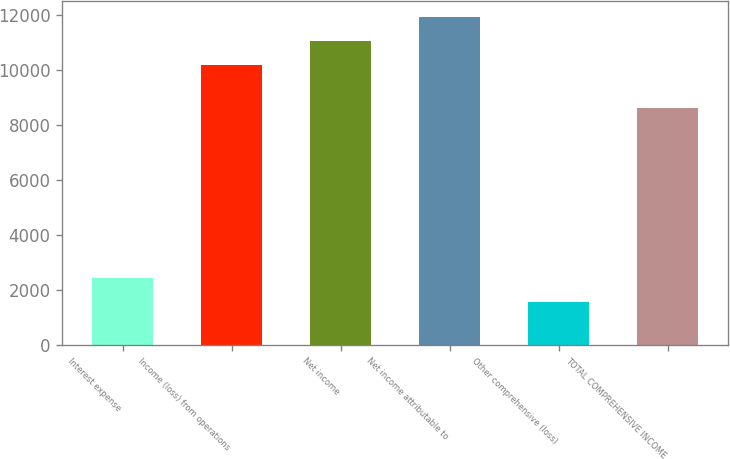<chart> <loc_0><loc_0><loc_500><loc_500><bar_chart><fcel>Interest expense<fcel>Income (loss) from operations<fcel>Net income<fcel>Net income attributable to<fcel>Other comprehensive (loss)<fcel>TOTAL COMPREHENSIVE INCOME<nl><fcel>2426.7<fcel>10200<fcel>11063.7<fcel>11927.4<fcel>1563<fcel>8637<nl></chart> 